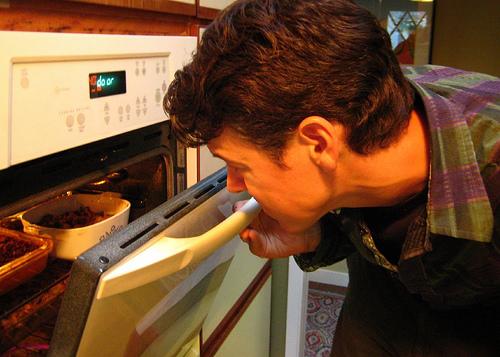Is he wearing a plaid shirt?
Answer briefly. Yes. What does the screen say?
Short answer required. Door. Is the stove full?
Write a very short answer. Yes. 